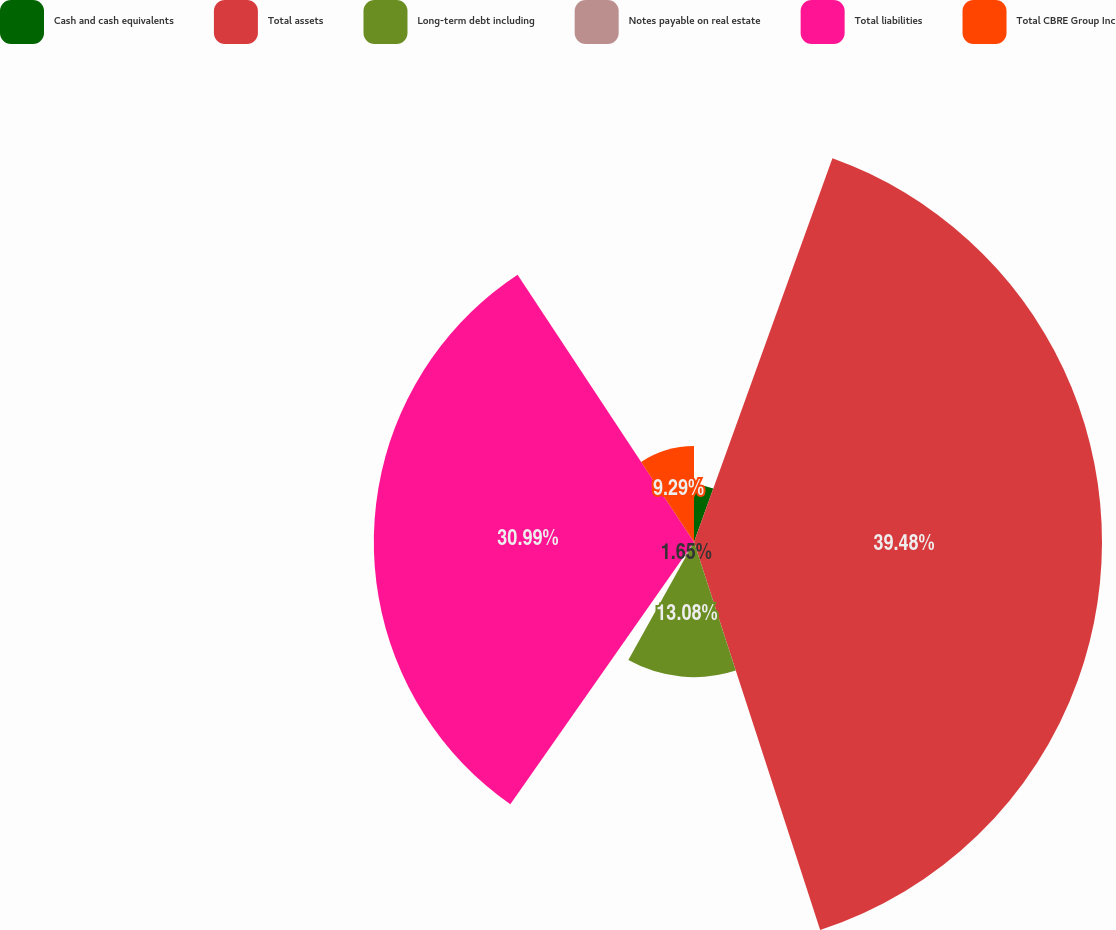Convert chart. <chart><loc_0><loc_0><loc_500><loc_500><pie_chart><fcel>Cash and cash equivalents<fcel>Total assets<fcel>Long-term debt including<fcel>Notes payable on real estate<fcel>Total liabilities<fcel>Total CBRE Group Inc<nl><fcel>5.51%<fcel>39.49%<fcel>13.08%<fcel>1.65%<fcel>30.99%<fcel>9.29%<nl></chart> 